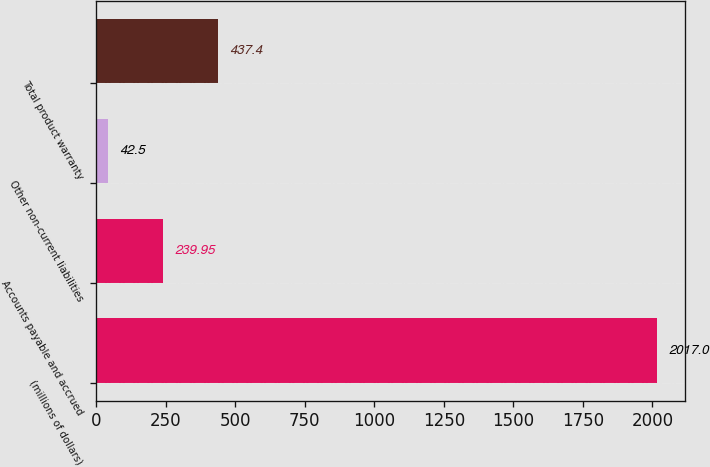<chart> <loc_0><loc_0><loc_500><loc_500><bar_chart><fcel>(millions of dollars)<fcel>Accounts payable and accrued<fcel>Other non-current liabilities<fcel>Total product warranty<nl><fcel>2017<fcel>239.95<fcel>42.5<fcel>437.4<nl></chart> 